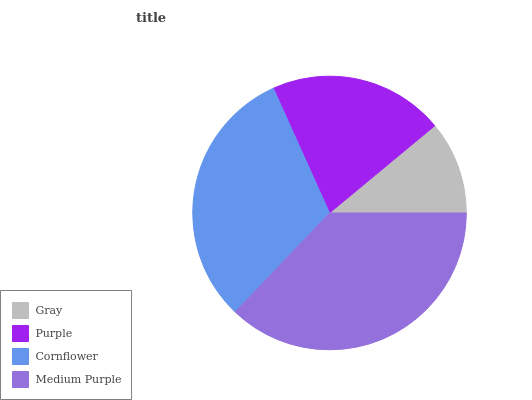Is Gray the minimum?
Answer yes or no. Yes. Is Medium Purple the maximum?
Answer yes or no. Yes. Is Purple the minimum?
Answer yes or no. No. Is Purple the maximum?
Answer yes or no. No. Is Purple greater than Gray?
Answer yes or no. Yes. Is Gray less than Purple?
Answer yes or no. Yes. Is Gray greater than Purple?
Answer yes or no. No. Is Purple less than Gray?
Answer yes or no. No. Is Cornflower the high median?
Answer yes or no. Yes. Is Purple the low median?
Answer yes or no. Yes. Is Medium Purple the high median?
Answer yes or no. No. Is Cornflower the low median?
Answer yes or no. No. 